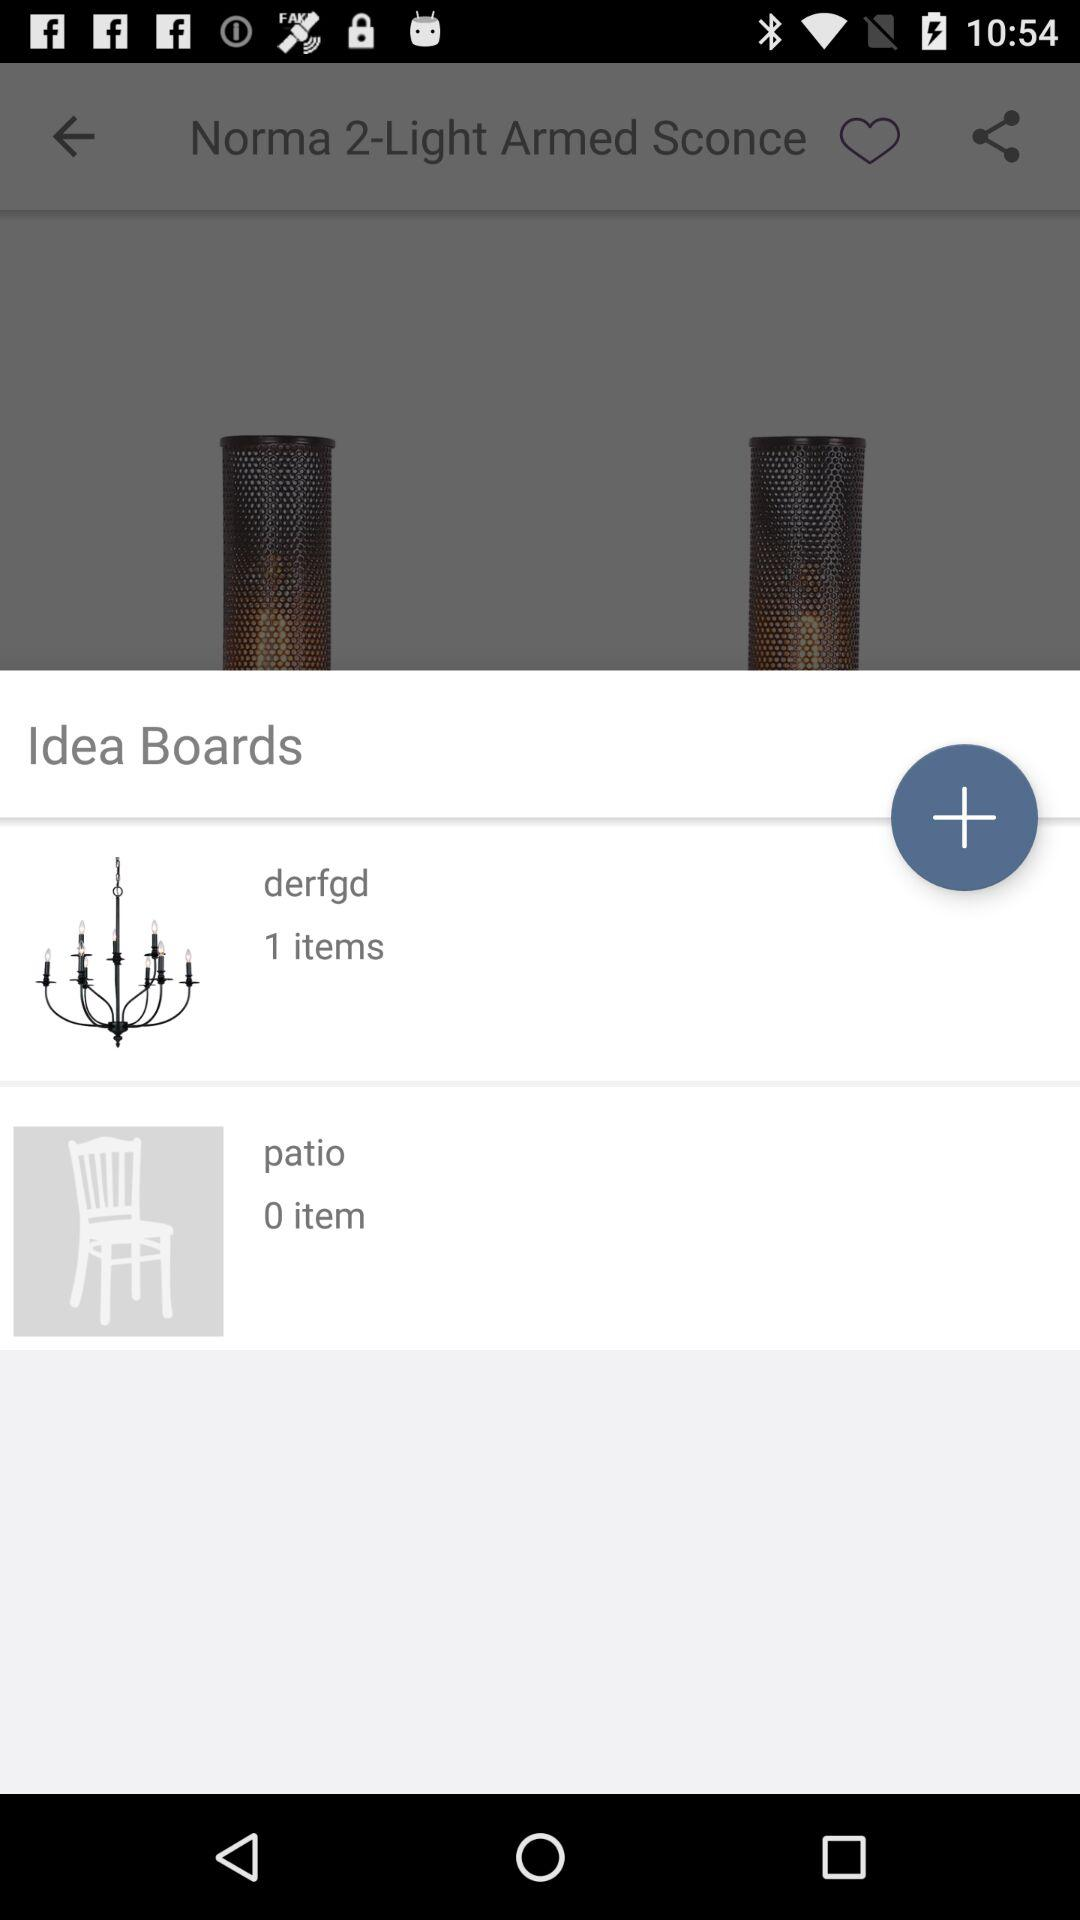How many items are there in the patio? There are 0 items. 